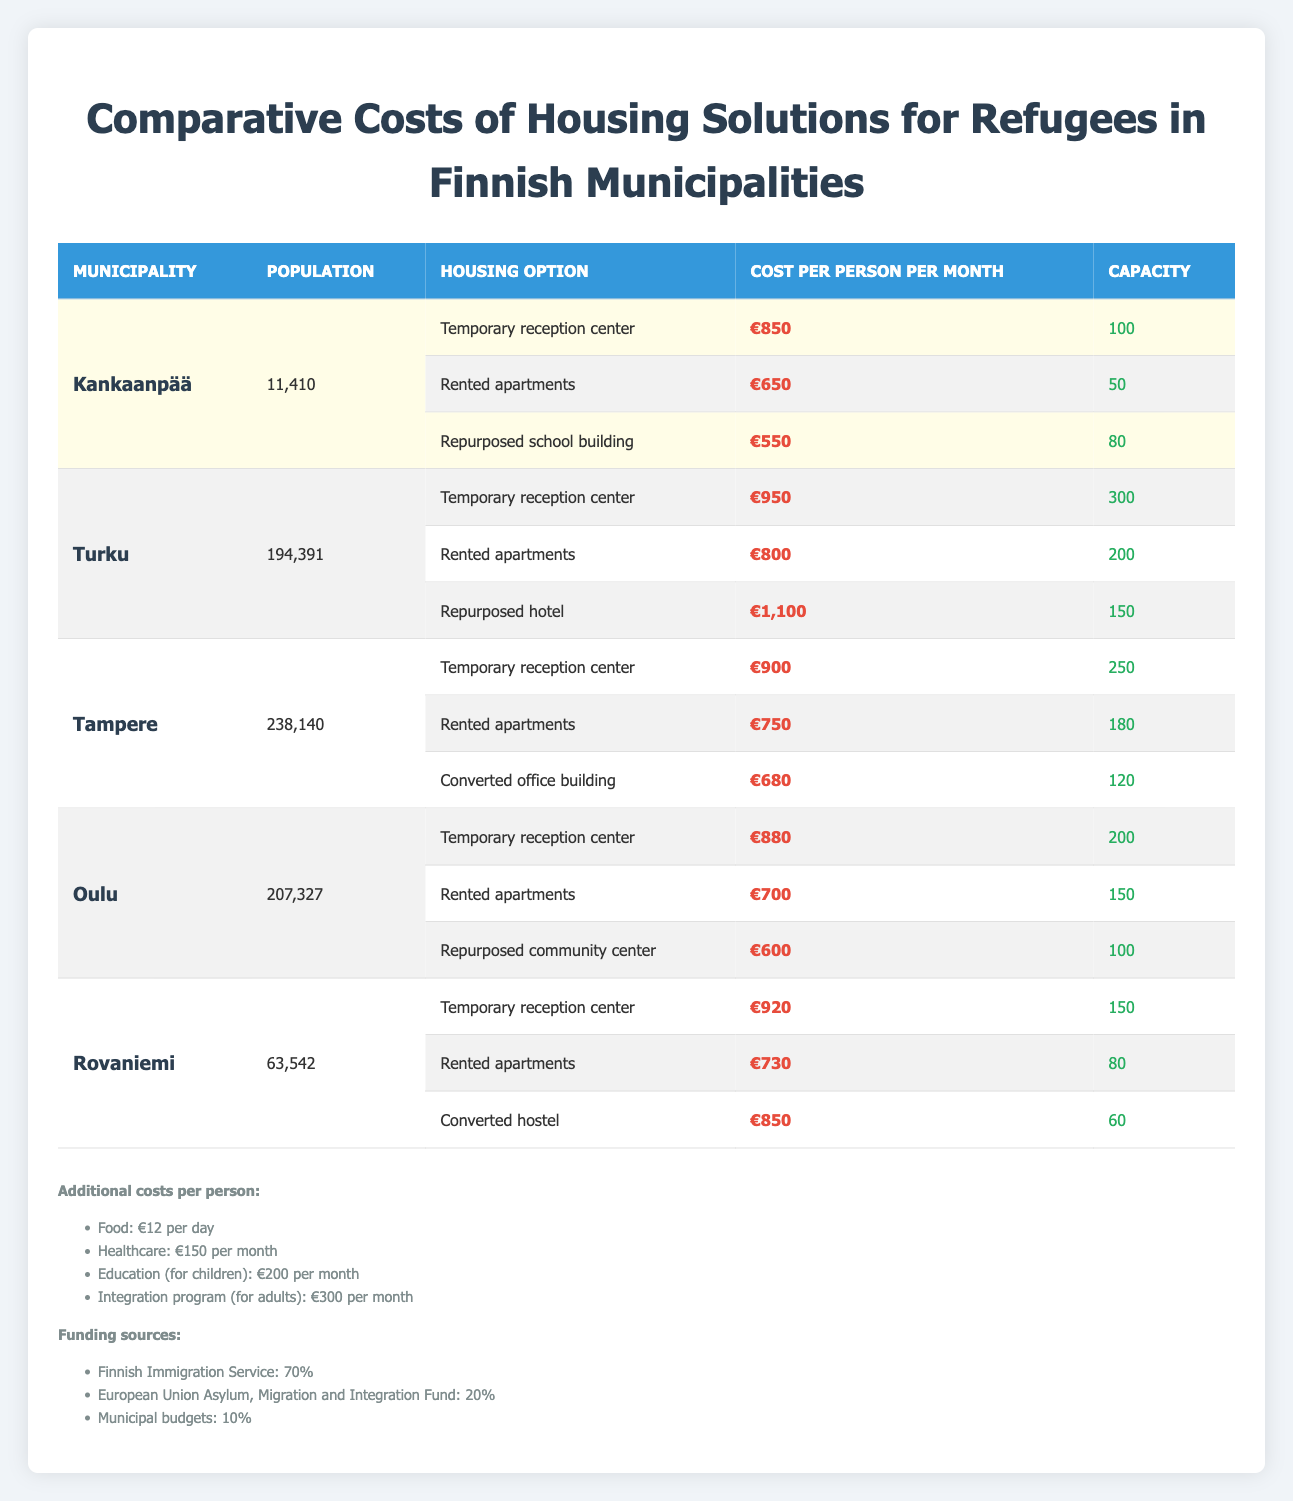What is the cost per person per month for rented apartments in Kankaanpää? In the table, under the "Kankaanpää" section, the housing option for "Rented apartments" lists the cost as €650 per person per month.
Answer: €650 Which municipality has the highest cost for temporary reception centers? To determine this, we compare the costs listed for "Temporary reception center" across all municipalities: Kankaanpää (€850), Turku (€950), Tampere (€900), Oulu (€880), and Rovaniemi (€920). Turku has the highest cost at €950.
Answer: Turku How much would it cost for food and healthcare per person for one month? The cost for food per person is €12 per day. Over a month (30 days), this totals €360 (12 * 30). The healthcare cost is €150 per month. Adding these amounts gives €360 + €150 = €510.
Answer: €510 Are the rented apartments in Kankaanpää cheaper than those in Oulu? In Kankaanpää, the rented apartments cost €650, while in Oulu, they cost €700. Since €650 is less than €700, the statement is true.
Answer: Yes What is the capacity of housing options in Turku that costs less than €900? In Turku, the "Rented apartments" cost €800 and have a capacity of 200, and the "Temporary reception center" and "Repurposed hotel" both exceed €900. Add the capacity of rented apartments, which equals 200.
Answer: 200 What is the total capacity of all housing options in Kankaanpää? The capacities for Kankaanpää's options are: Temporary reception center (100), Rented apartments (50), and Repurposed school building (80). The total capacity is 100 + 50 + 80 = 230.
Answer: 230 Which municipality offers the lowest cost for repurposed housing? We examine the repurposed housing options: Kankaanpää (Repurposed school building - €550), Turku (Repurposed hotel - €1,100), Oulu (Repurposed community center - €600), and Rovaniemi (Converted hostel - €850). Kankaanpää has the lowest cost at €550.
Answer: Kankaanpää If the integration program costs €300 per adult per month, how much would it be for 5 adults in total? The integration program cost for one adult is €300 per month, so for 5 adults, multiply: 300 * 5 = 1,500.
Answer: €1,500 Which municipality has a population greater than 200,000? A quick check shows that Tampere (238,140), Turku (194,391), Oulu (207,327), and Rovaniemi (63,542). Only Tampere and Oulu have populations over 200,000.
Answer: Yes 